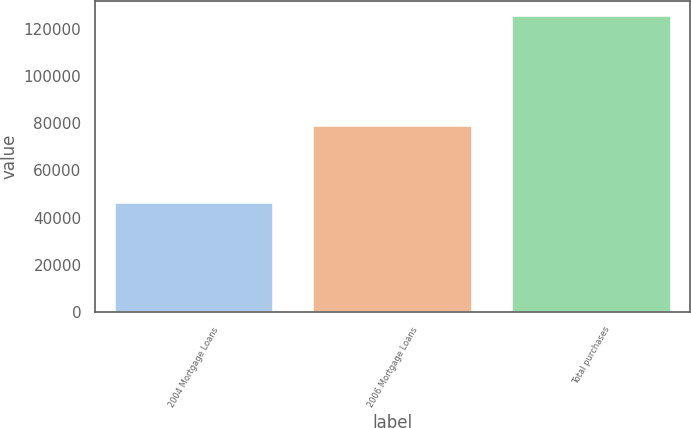Convert chart. <chart><loc_0><loc_0><loc_500><loc_500><bar_chart><fcel>2004 Mortgage Loans<fcel>2006 Mortgage Loans<fcel>Total purchases<nl><fcel>46315<fcel>78979<fcel>125294<nl></chart> 